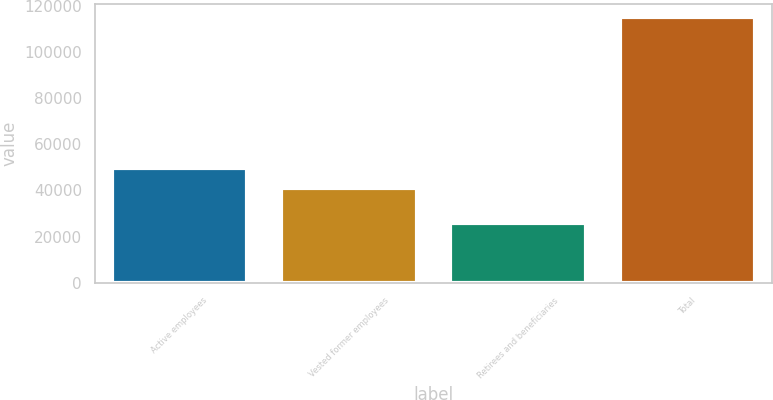Convert chart. <chart><loc_0><loc_0><loc_500><loc_500><bar_chart><fcel>Active employees<fcel>Vested former employees<fcel>Retirees and beneficiaries<fcel>Total<nl><fcel>49900<fcel>41000<fcel>26000<fcel>115000<nl></chart> 